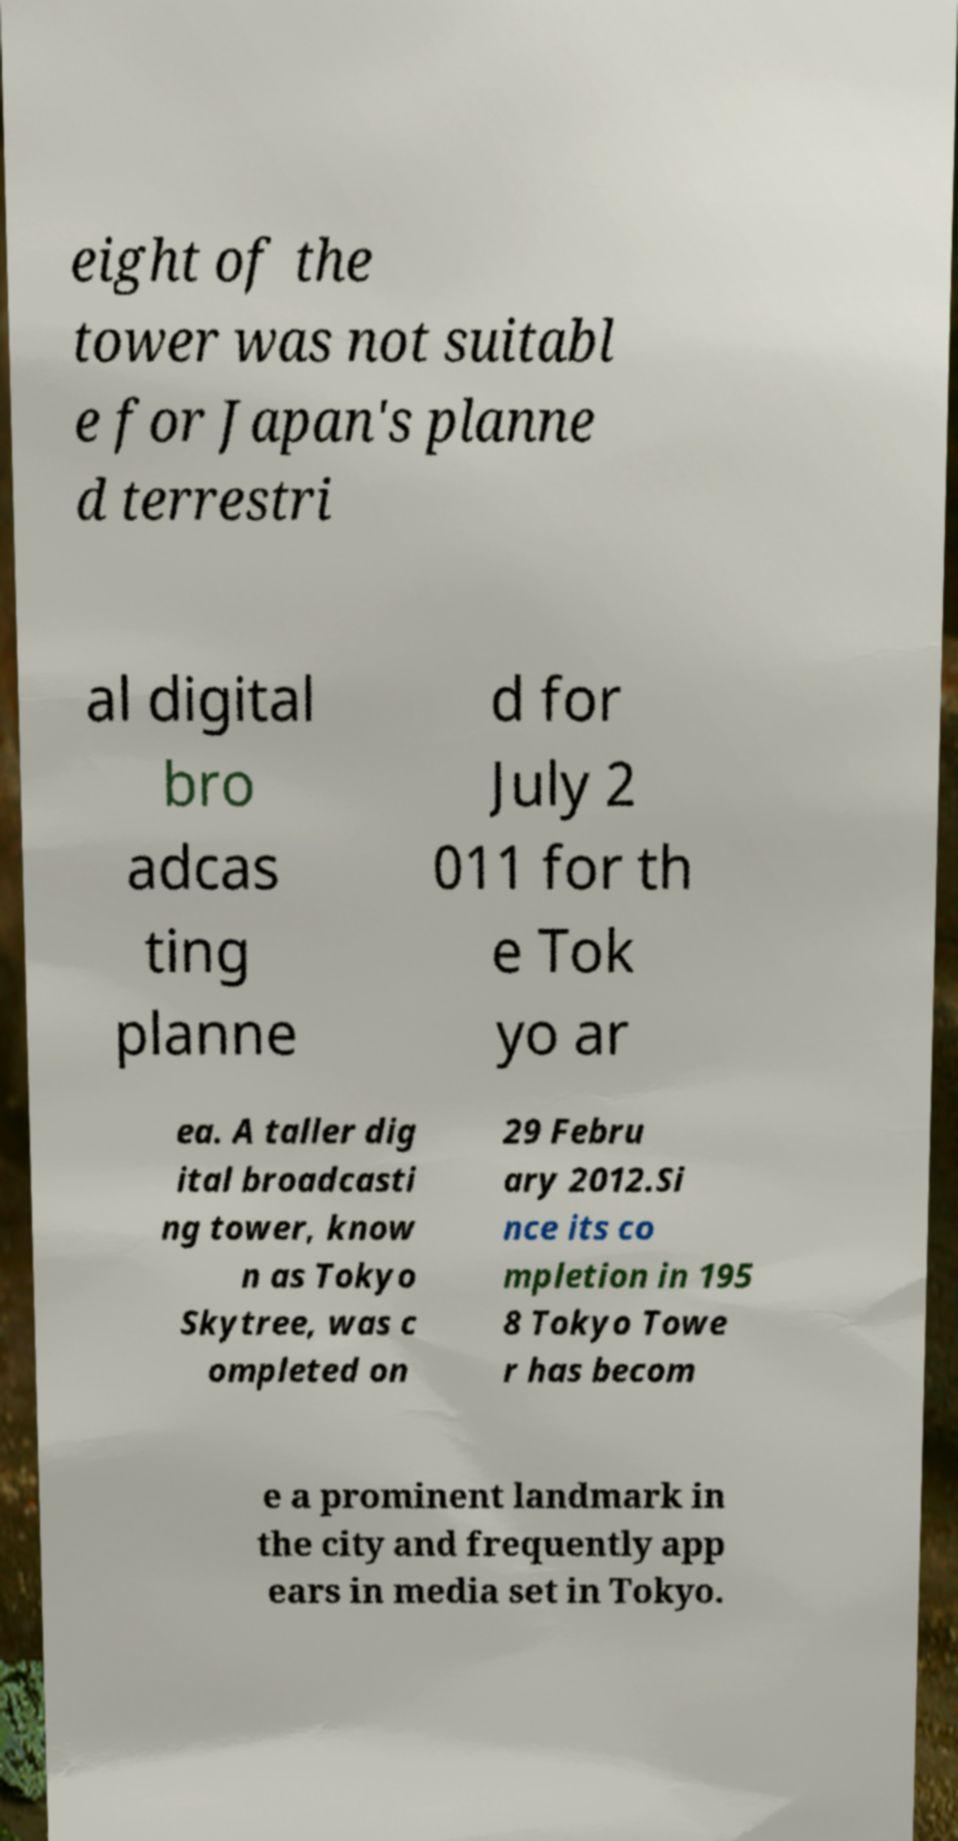Can you accurately transcribe the text from the provided image for me? eight of the tower was not suitabl e for Japan's planne d terrestri al digital bro adcas ting planne d for July 2 011 for th e Tok yo ar ea. A taller dig ital broadcasti ng tower, know n as Tokyo Skytree, was c ompleted on 29 Febru ary 2012.Si nce its co mpletion in 195 8 Tokyo Towe r has becom e a prominent landmark in the city and frequently app ears in media set in Tokyo. 